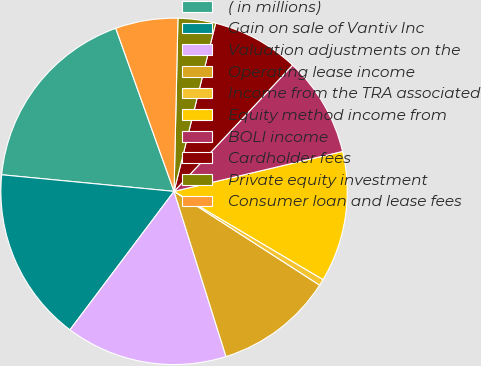Convert chart to OTSL. <chart><loc_0><loc_0><loc_500><loc_500><pie_chart><fcel>( in millions)<fcel>Gain on sale of Vantiv Inc<fcel>Valuation adjustments on the<fcel>Operating lease income<fcel>Income from the TRA associated<fcel>Equity method income from<fcel>BOLI income<fcel>Cardholder fees<fcel>Private equity investment<fcel>Consumer loan and lease fees<nl><fcel>18.01%<fcel>16.27%<fcel>15.11%<fcel>11.04%<fcel>0.6%<fcel>12.21%<fcel>9.3%<fcel>8.14%<fcel>3.5%<fcel>5.82%<nl></chart> 